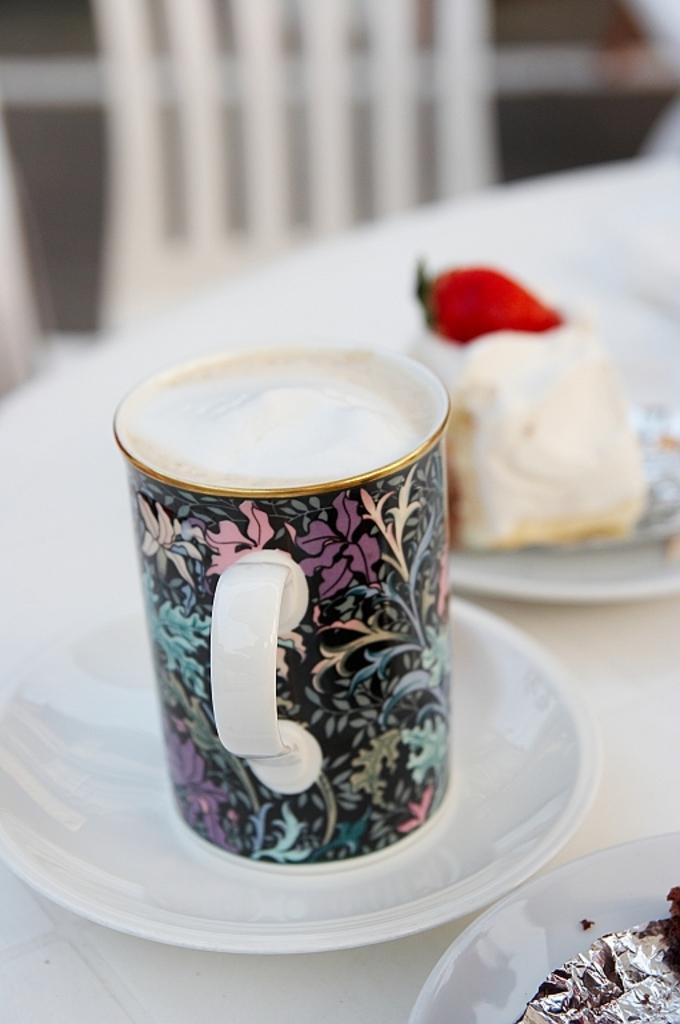In one or two sentences, can you explain what this image depicts? In this picture we can see a cup and this is the saucer. And there is a food on the plate. And this is the chair. 